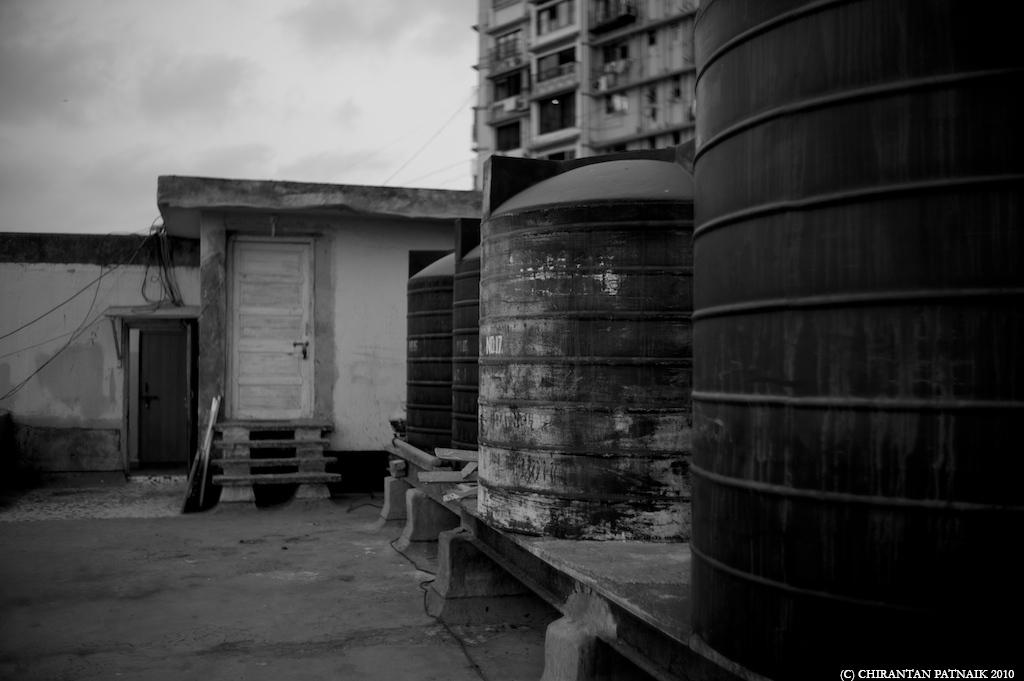What structures are present in the image? There are water tanks in the image. What can be seen in the background of the image? There are buildings and the sky visible in the background of the image. What is the color scheme of the image? The image is black and white. Where are the flowers and basket located in the image? There are no flowers or basket present in the image. 